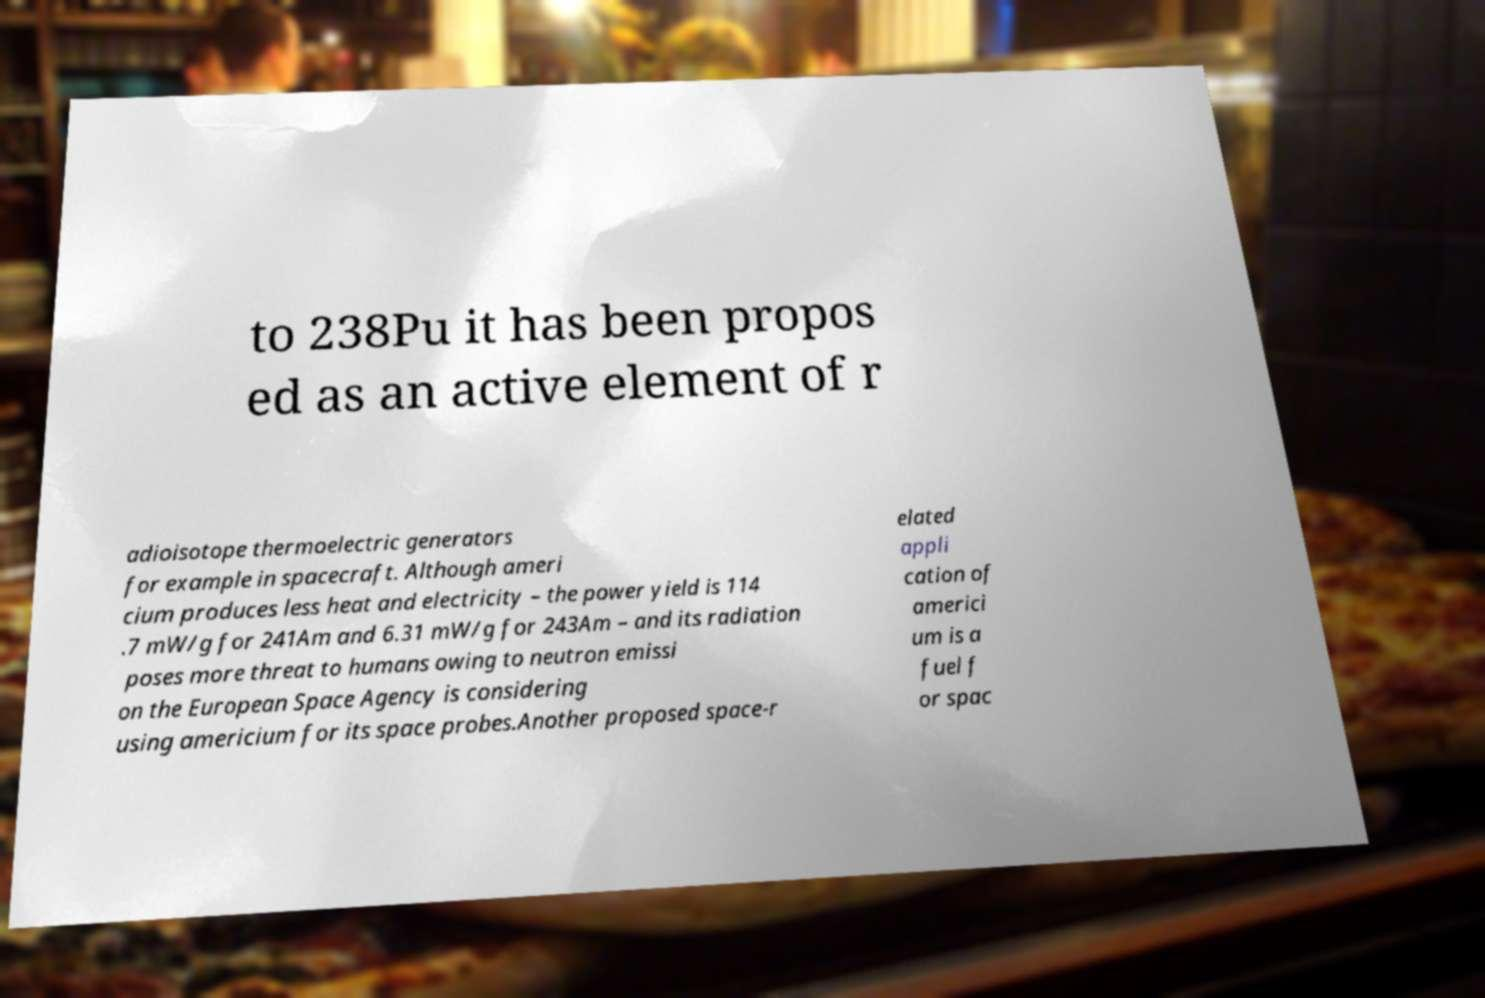Could you extract and type out the text from this image? to 238Pu it has been propos ed as an active element of r adioisotope thermoelectric generators for example in spacecraft. Although ameri cium produces less heat and electricity – the power yield is 114 .7 mW/g for 241Am and 6.31 mW/g for 243Am – and its radiation poses more threat to humans owing to neutron emissi on the European Space Agency is considering using americium for its space probes.Another proposed space-r elated appli cation of americi um is a fuel f or spac 